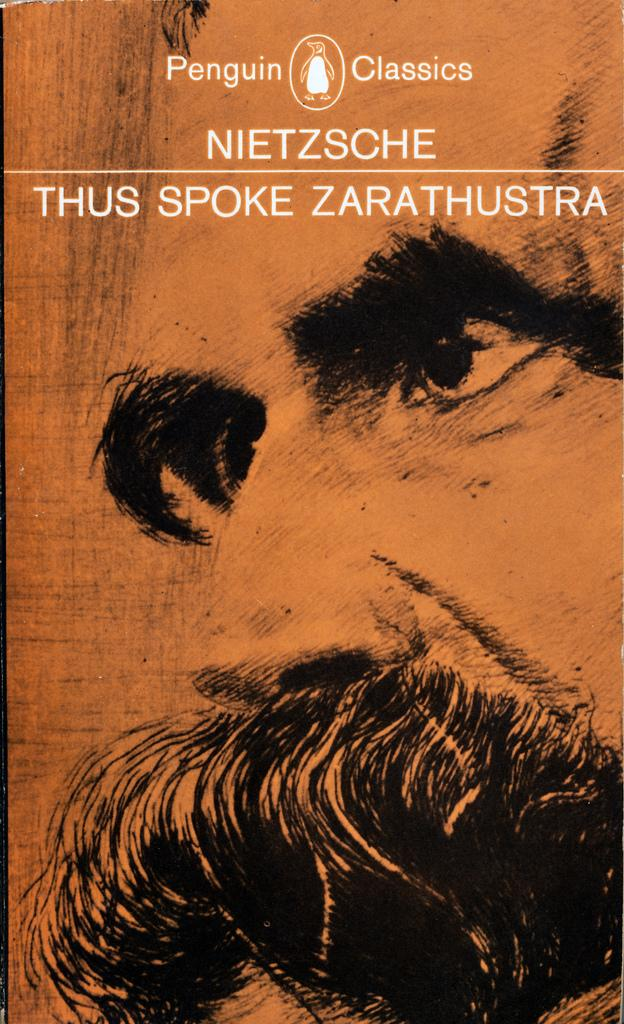What is present in the image that contains both an image and text? There is a poster in the image that contains both an image and text. Can you describe the image on the poster? Unfortunately, the specific image on the poster cannot be described with the given facts. What type of information might be conveyed by the text on the poster? The text on the poster could convey various types of information, such as a message, a slogan, or instructions. What color is the gold throat depicted on the poster? There is no mention of gold or a throat in the image, so this question cannot be answered. 